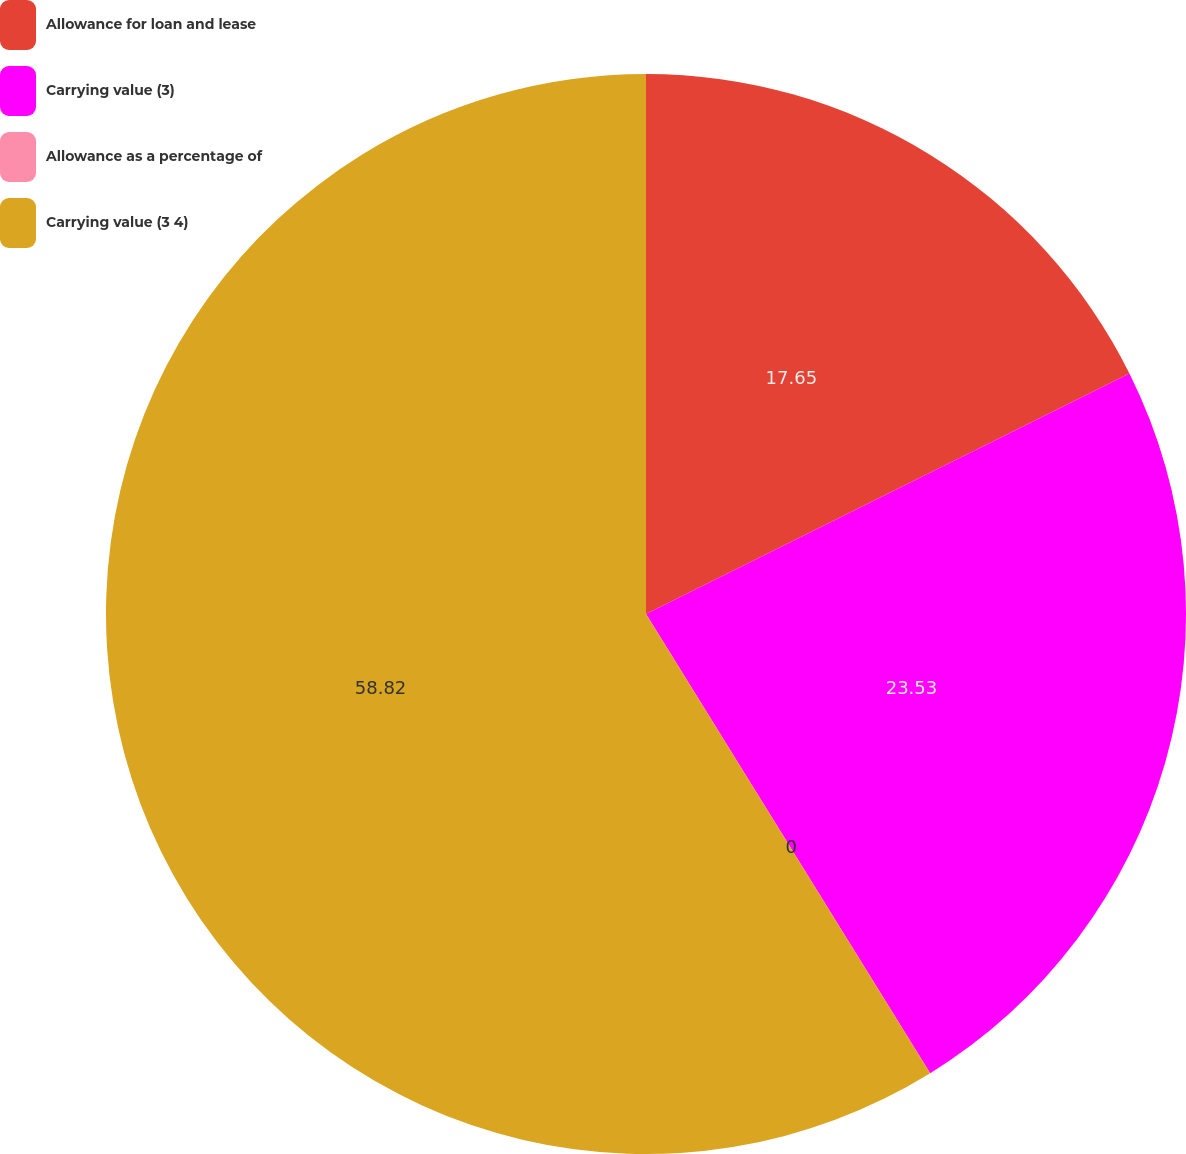Convert chart. <chart><loc_0><loc_0><loc_500><loc_500><pie_chart><fcel>Allowance for loan and lease<fcel>Carrying value (3)<fcel>Allowance as a percentage of<fcel>Carrying value (3 4)<nl><fcel>17.65%<fcel>23.53%<fcel>0.0%<fcel>58.82%<nl></chart> 